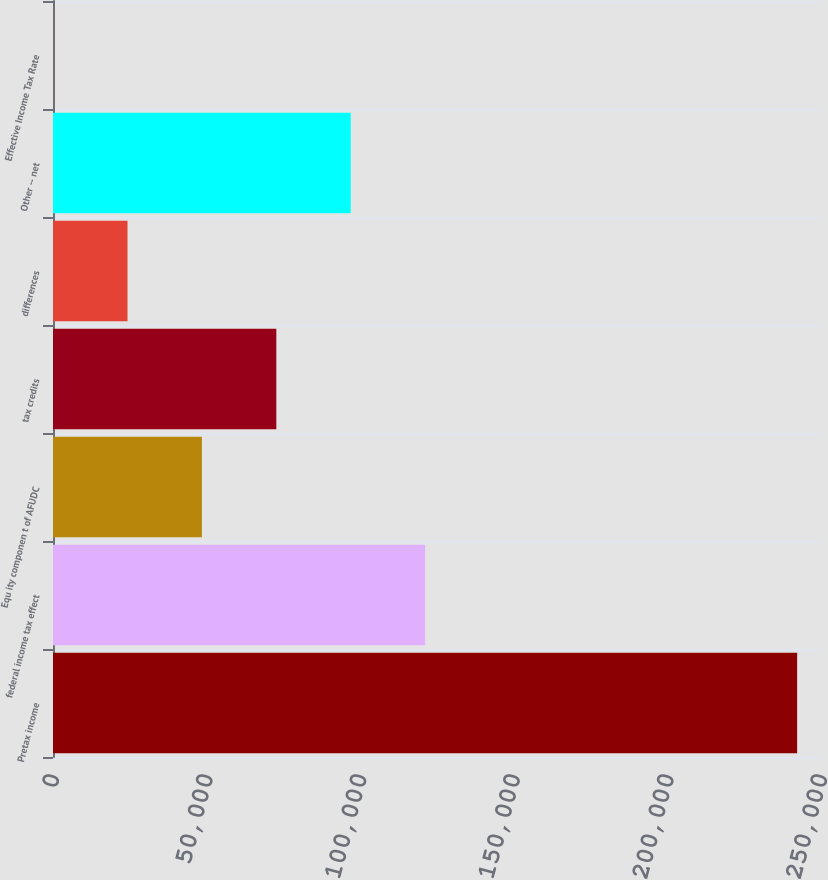Convert chart to OTSL. <chart><loc_0><loc_0><loc_500><loc_500><bar_chart><fcel>Pretax income<fcel>federal income tax effect<fcel>Equ ity componen t of AFUDC<fcel>tax credits<fcel>differences<fcel>Other -- net<fcel>Effective Income Tax Rate<nl><fcel>242232<fcel>121134<fcel>48475.8<fcel>72695.4<fcel>24256.3<fcel>96914.9<fcel>36.8<nl></chart> 